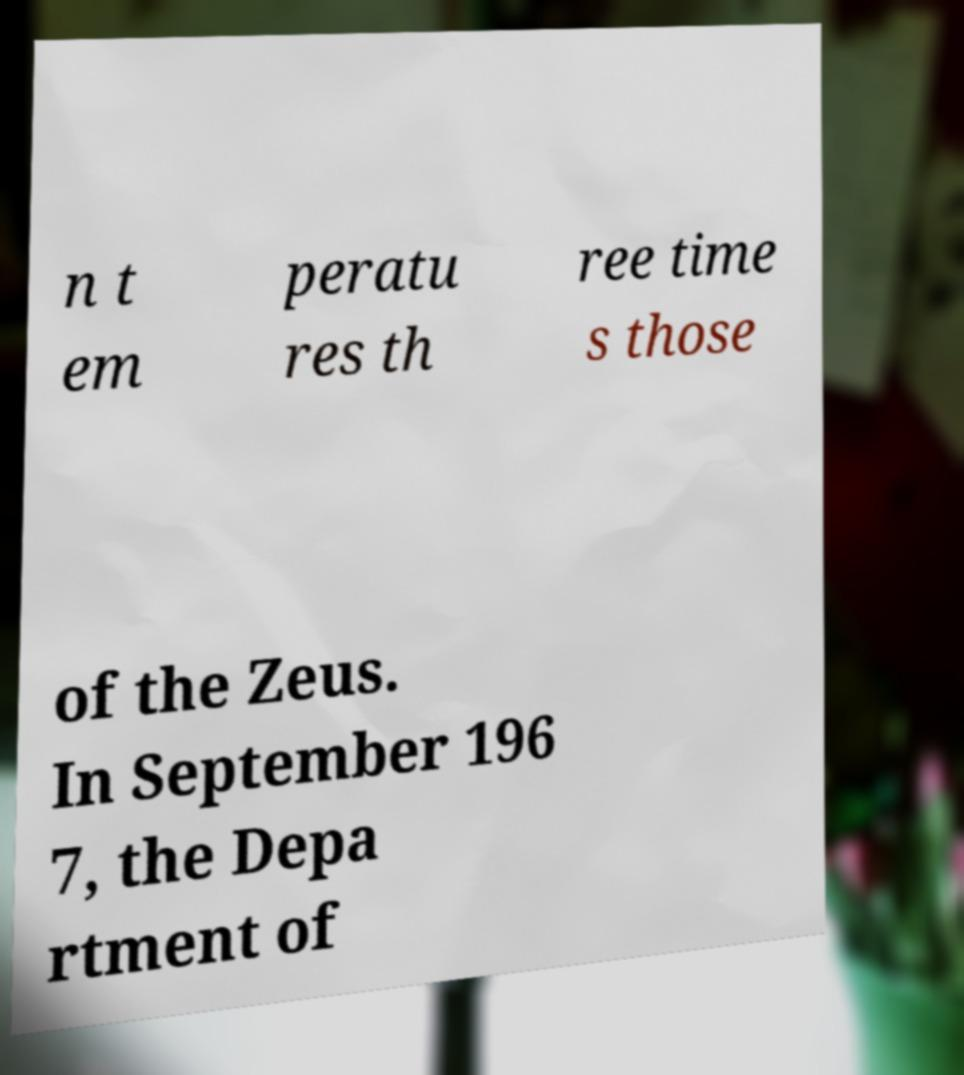I need the written content from this picture converted into text. Can you do that? n t em peratu res th ree time s those of the Zeus. In September 196 7, the Depa rtment of 